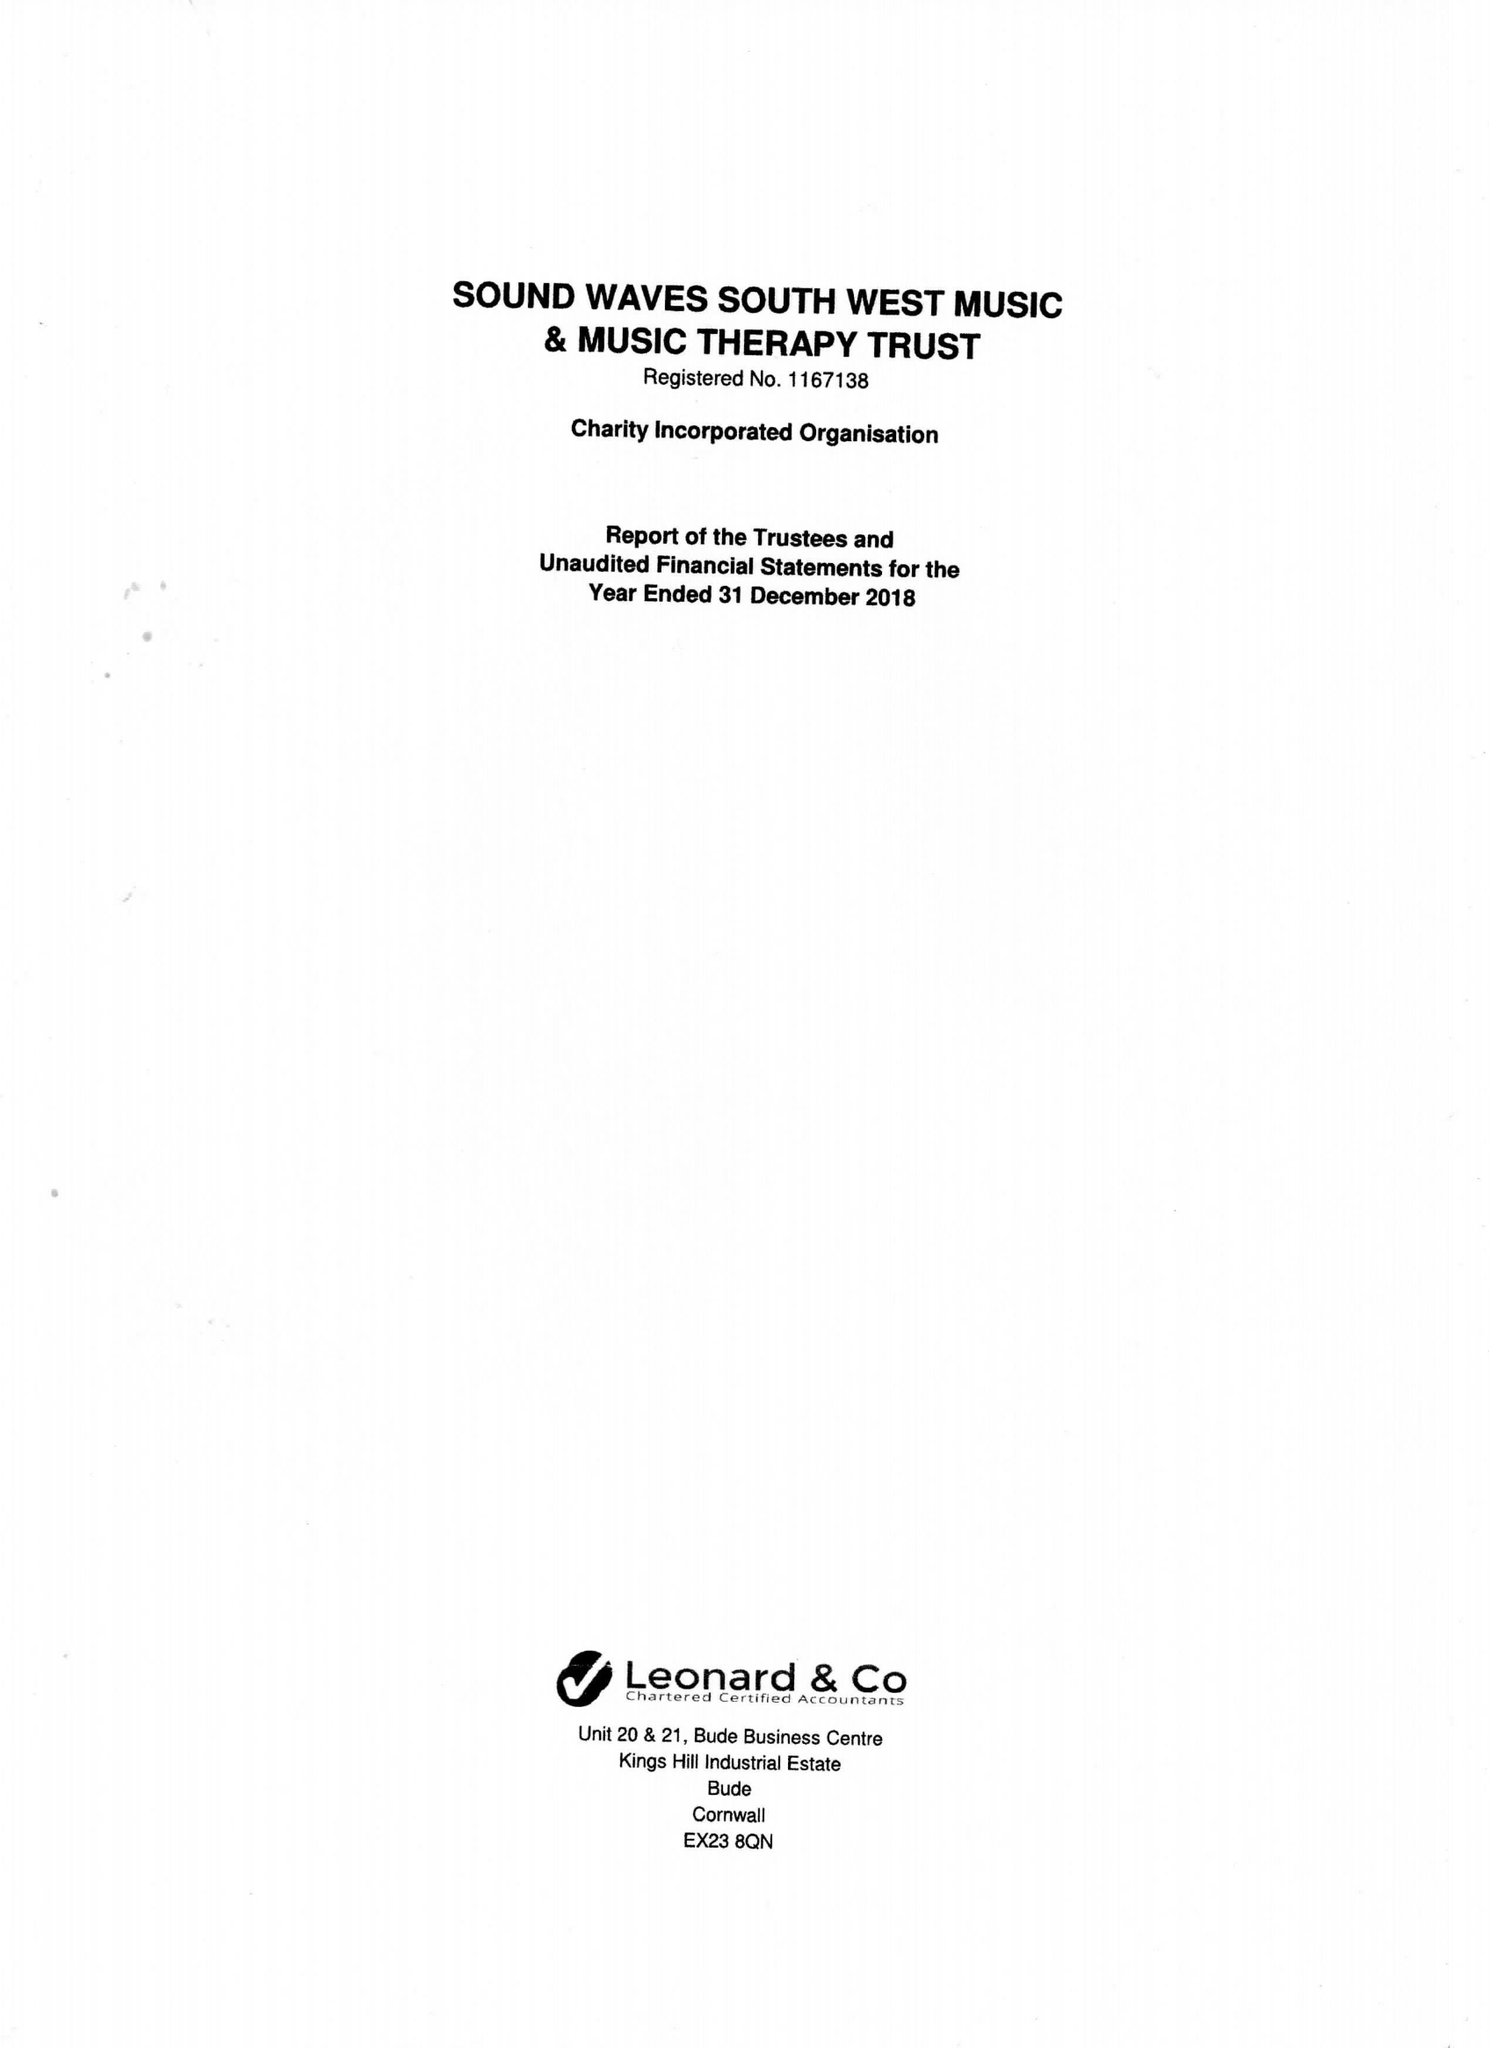What is the value for the address__postcode?
Answer the question using a single word or phrase. EX23 9JN 